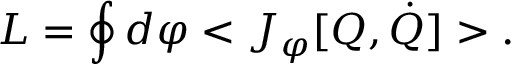Convert formula to latex. <formula><loc_0><loc_0><loc_500><loc_500>L = \oint d \varphi < J _ { \varphi } [ Q , \dot { Q } ] > .</formula> 